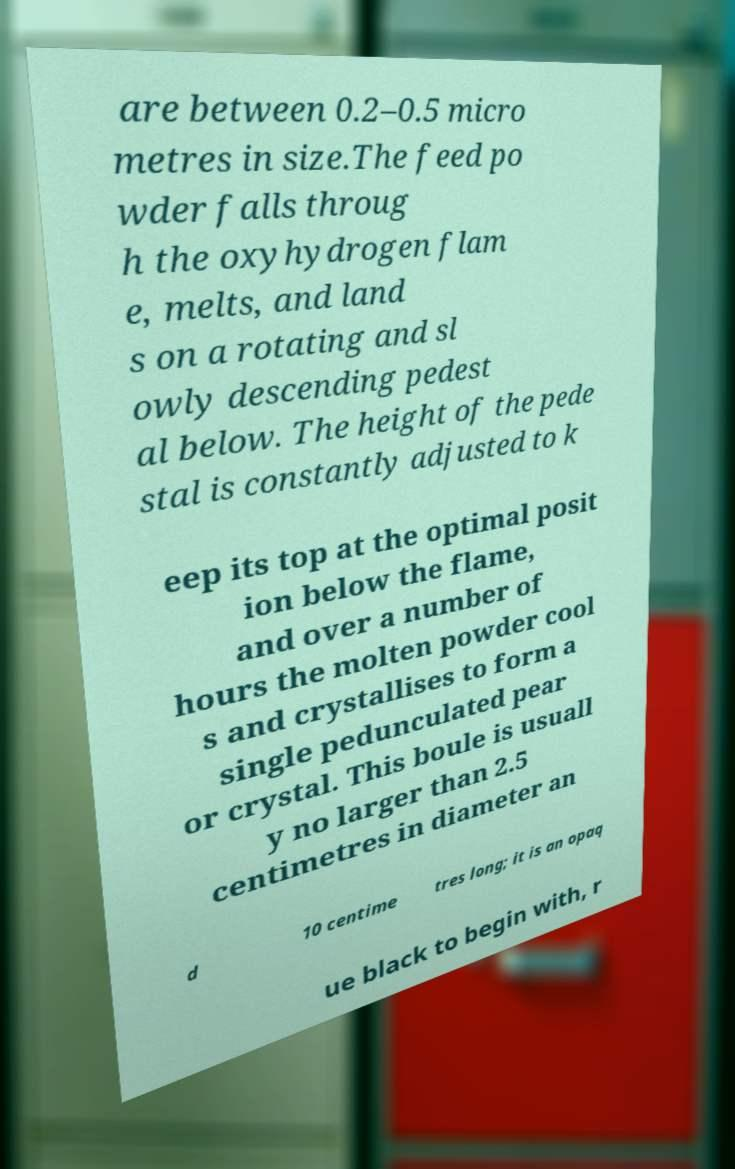There's text embedded in this image that I need extracted. Can you transcribe it verbatim? are between 0.2–0.5 micro metres in size.The feed po wder falls throug h the oxyhydrogen flam e, melts, and land s on a rotating and sl owly descending pedest al below. The height of the pede stal is constantly adjusted to k eep its top at the optimal posit ion below the flame, and over a number of hours the molten powder cool s and crystallises to form a single pedunculated pear or crystal. This boule is usuall y no larger than 2.5 centimetres in diameter an d 10 centime tres long; it is an opaq ue black to begin with, r 